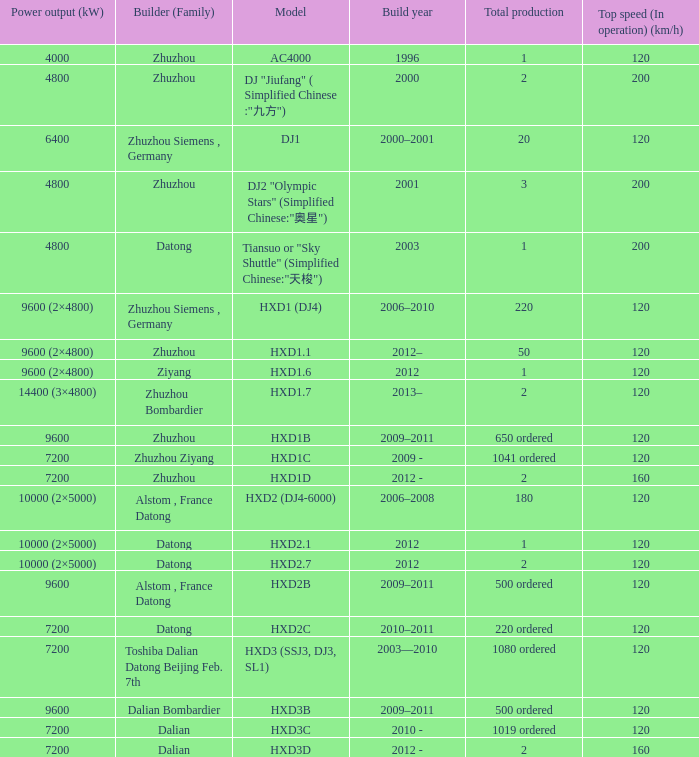What is the power output (kw) of builder zhuzhou, model hxd1d, with a total production of 2? 7200.0. 